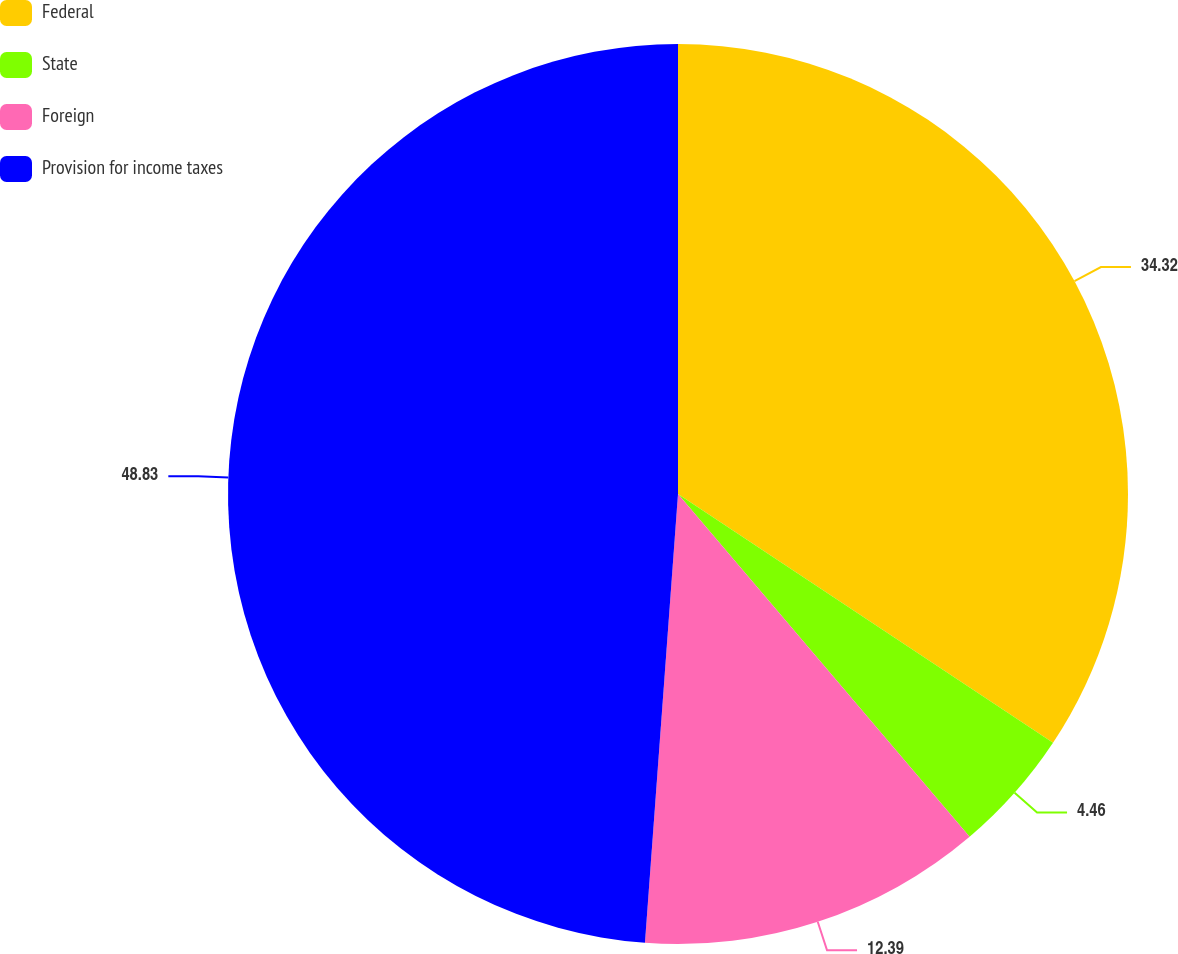Convert chart. <chart><loc_0><loc_0><loc_500><loc_500><pie_chart><fcel>Federal<fcel>State<fcel>Foreign<fcel>Provision for income taxes<nl><fcel>34.32%<fcel>4.46%<fcel>12.39%<fcel>48.83%<nl></chart> 